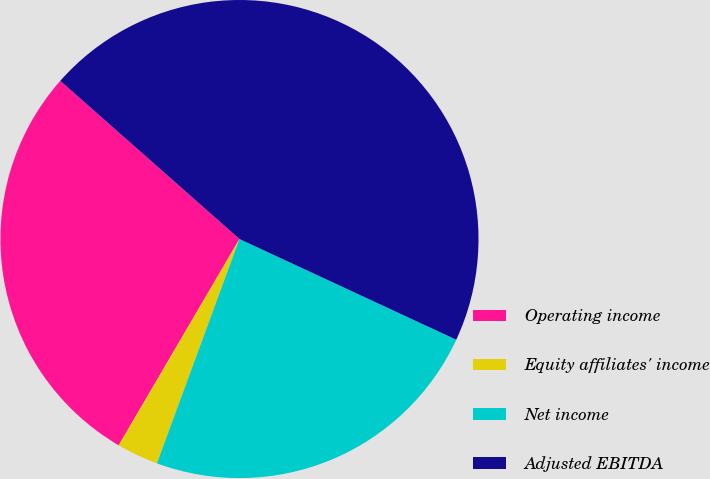Convert chart. <chart><loc_0><loc_0><loc_500><loc_500><pie_chart><fcel>Operating income<fcel>Equity affiliates' income<fcel>Net income<fcel>Adjusted EBITDA<nl><fcel>28.08%<fcel>2.82%<fcel>23.69%<fcel>45.41%<nl></chart> 